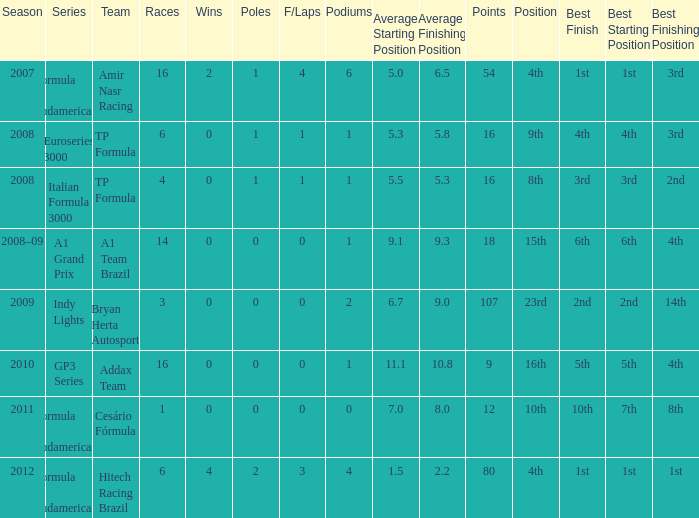How many points did he win in the race with more than 1.0 poles? 80.0. 